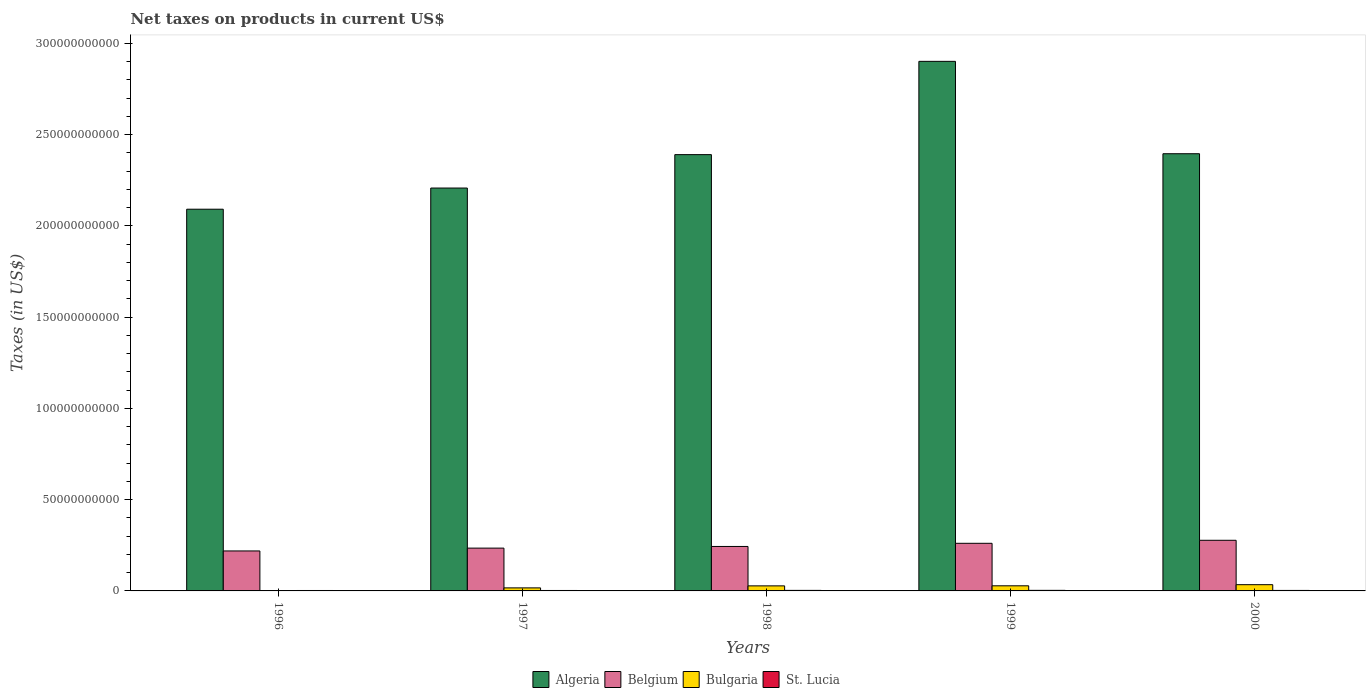How many groups of bars are there?
Your response must be concise. 5. Are the number of bars per tick equal to the number of legend labels?
Offer a terse response. Yes. In how many cases, is the number of bars for a given year not equal to the number of legend labels?
Your response must be concise. 0. What is the net taxes on products in Belgium in 1996?
Provide a short and direct response. 2.19e+1. Across all years, what is the maximum net taxes on products in Belgium?
Provide a short and direct response. 2.77e+1. Across all years, what is the minimum net taxes on products in Belgium?
Your answer should be compact. 2.19e+1. What is the total net taxes on products in St. Lucia in the graph?
Provide a succinct answer. 1.35e+09. What is the difference between the net taxes on products in Belgium in 1997 and that in 2000?
Provide a succinct answer. -4.29e+09. What is the difference between the net taxes on products in Belgium in 1998 and the net taxes on products in Algeria in 1999?
Offer a very short reply. -2.66e+11. What is the average net taxes on products in Belgium per year?
Your answer should be compact. 2.47e+1. In the year 1996, what is the difference between the net taxes on products in Bulgaria and net taxes on products in Algeria?
Offer a terse response. -2.09e+11. What is the ratio of the net taxes on products in Belgium in 1996 to that in 1999?
Provide a short and direct response. 0.84. What is the difference between the highest and the second highest net taxes on products in St. Lucia?
Provide a succinct answer. 1.72e+07. What is the difference between the highest and the lowest net taxes on products in Bulgaria?
Offer a very short reply. 3.23e+09. Is it the case that in every year, the sum of the net taxes on products in St. Lucia and net taxes on products in Algeria is greater than the sum of net taxes on products in Belgium and net taxes on products in Bulgaria?
Offer a terse response. No. What does the 3rd bar from the left in 1998 represents?
Keep it short and to the point. Bulgaria. What does the 1st bar from the right in 1996 represents?
Your response must be concise. St. Lucia. Is it the case that in every year, the sum of the net taxes on products in Bulgaria and net taxes on products in St. Lucia is greater than the net taxes on products in Belgium?
Offer a very short reply. No. How many bars are there?
Make the answer very short. 20. How many years are there in the graph?
Give a very brief answer. 5. What is the difference between two consecutive major ticks on the Y-axis?
Provide a short and direct response. 5.00e+1. How many legend labels are there?
Offer a terse response. 4. What is the title of the graph?
Keep it short and to the point. Net taxes on products in current US$. What is the label or title of the Y-axis?
Keep it short and to the point. Taxes (in US$). What is the Taxes (in US$) of Algeria in 1996?
Offer a terse response. 2.09e+11. What is the Taxes (in US$) of Belgium in 1996?
Offer a very short reply. 2.19e+1. What is the Taxes (in US$) in Bulgaria in 1996?
Your answer should be compact. 1.82e+08. What is the Taxes (in US$) in St. Lucia in 1996?
Your response must be concise. 2.35e+08. What is the Taxes (in US$) in Algeria in 1997?
Your answer should be compact. 2.21e+11. What is the Taxes (in US$) in Belgium in 1997?
Offer a terse response. 2.34e+1. What is the Taxes (in US$) of Bulgaria in 1997?
Offer a very short reply. 1.66e+09. What is the Taxes (in US$) in St. Lucia in 1997?
Provide a succinct answer. 2.40e+08. What is the Taxes (in US$) in Algeria in 1998?
Provide a succinct answer. 2.39e+11. What is the Taxes (in US$) in Belgium in 1998?
Your answer should be very brief. 2.44e+1. What is the Taxes (in US$) of Bulgaria in 1998?
Offer a very short reply. 2.77e+09. What is the Taxes (in US$) in St. Lucia in 1998?
Offer a very short reply. 2.94e+08. What is the Taxes (in US$) in Algeria in 1999?
Your answer should be very brief. 2.90e+11. What is the Taxes (in US$) in Belgium in 1999?
Provide a short and direct response. 2.61e+1. What is the Taxes (in US$) in Bulgaria in 1999?
Ensure brevity in your answer.  2.80e+09. What is the Taxes (in US$) in St. Lucia in 1999?
Give a very brief answer. 3.11e+08. What is the Taxes (in US$) in Algeria in 2000?
Provide a short and direct response. 2.40e+11. What is the Taxes (in US$) in Belgium in 2000?
Ensure brevity in your answer.  2.77e+1. What is the Taxes (in US$) in Bulgaria in 2000?
Your response must be concise. 3.42e+09. What is the Taxes (in US$) of St. Lucia in 2000?
Make the answer very short. 2.73e+08. Across all years, what is the maximum Taxes (in US$) of Algeria?
Give a very brief answer. 2.90e+11. Across all years, what is the maximum Taxes (in US$) of Belgium?
Your answer should be very brief. 2.77e+1. Across all years, what is the maximum Taxes (in US$) of Bulgaria?
Your response must be concise. 3.42e+09. Across all years, what is the maximum Taxes (in US$) in St. Lucia?
Provide a succinct answer. 3.11e+08. Across all years, what is the minimum Taxes (in US$) of Algeria?
Offer a very short reply. 2.09e+11. Across all years, what is the minimum Taxes (in US$) in Belgium?
Your answer should be very brief. 2.19e+1. Across all years, what is the minimum Taxes (in US$) of Bulgaria?
Offer a terse response. 1.82e+08. Across all years, what is the minimum Taxes (in US$) in St. Lucia?
Keep it short and to the point. 2.35e+08. What is the total Taxes (in US$) in Algeria in the graph?
Provide a short and direct response. 1.20e+12. What is the total Taxes (in US$) in Belgium in the graph?
Provide a short and direct response. 1.24e+11. What is the total Taxes (in US$) of Bulgaria in the graph?
Offer a terse response. 1.08e+1. What is the total Taxes (in US$) in St. Lucia in the graph?
Give a very brief answer. 1.35e+09. What is the difference between the Taxes (in US$) in Algeria in 1996 and that in 1997?
Provide a succinct answer. -1.16e+1. What is the difference between the Taxes (in US$) in Belgium in 1996 and that in 1997?
Ensure brevity in your answer.  -1.55e+09. What is the difference between the Taxes (in US$) of Bulgaria in 1996 and that in 1997?
Your answer should be very brief. -1.48e+09. What is the difference between the Taxes (in US$) in St. Lucia in 1996 and that in 1997?
Offer a very short reply. -5.30e+06. What is the difference between the Taxes (in US$) in Algeria in 1996 and that in 1998?
Ensure brevity in your answer.  -2.99e+1. What is the difference between the Taxes (in US$) in Belgium in 1996 and that in 1998?
Keep it short and to the point. -2.46e+09. What is the difference between the Taxes (in US$) of Bulgaria in 1996 and that in 1998?
Your answer should be very brief. -2.58e+09. What is the difference between the Taxes (in US$) of St. Lucia in 1996 and that in 1998?
Ensure brevity in your answer.  -5.86e+07. What is the difference between the Taxes (in US$) of Algeria in 1996 and that in 1999?
Your answer should be compact. -8.10e+1. What is the difference between the Taxes (in US$) of Belgium in 1996 and that in 1999?
Your answer should be compact. -4.19e+09. What is the difference between the Taxes (in US$) of Bulgaria in 1996 and that in 1999?
Provide a short and direct response. -2.62e+09. What is the difference between the Taxes (in US$) in St. Lucia in 1996 and that in 1999?
Give a very brief answer. -7.59e+07. What is the difference between the Taxes (in US$) in Algeria in 1996 and that in 2000?
Ensure brevity in your answer.  -3.04e+1. What is the difference between the Taxes (in US$) in Belgium in 1996 and that in 2000?
Ensure brevity in your answer.  -5.84e+09. What is the difference between the Taxes (in US$) in Bulgaria in 1996 and that in 2000?
Provide a short and direct response. -3.23e+09. What is the difference between the Taxes (in US$) in St. Lucia in 1996 and that in 2000?
Your answer should be compact. -3.77e+07. What is the difference between the Taxes (in US$) of Algeria in 1997 and that in 1998?
Offer a terse response. -1.83e+1. What is the difference between the Taxes (in US$) in Belgium in 1997 and that in 1998?
Offer a very short reply. -9.08e+08. What is the difference between the Taxes (in US$) in Bulgaria in 1997 and that in 1998?
Provide a short and direct response. -1.11e+09. What is the difference between the Taxes (in US$) of St. Lucia in 1997 and that in 1998?
Keep it short and to the point. -5.33e+07. What is the difference between the Taxes (in US$) in Algeria in 1997 and that in 1999?
Give a very brief answer. -6.94e+1. What is the difference between the Taxes (in US$) of Belgium in 1997 and that in 1999?
Your answer should be compact. -2.64e+09. What is the difference between the Taxes (in US$) in Bulgaria in 1997 and that in 1999?
Your answer should be compact. -1.14e+09. What is the difference between the Taxes (in US$) of St. Lucia in 1997 and that in 1999?
Your answer should be very brief. -7.06e+07. What is the difference between the Taxes (in US$) of Algeria in 1997 and that in 2000?
Provide a succinct answer. -1.88e+1. What is the difference between the Taxes (in US$) of Belgium in 1997 and that in 2000?
Provide a short and direct response. -4.29e+09. What is the difference between the Taxes (in US$) of Bulgaria in 1997 and that in 2000?
Your answer should be compact. -1.76e+09. What is the difference between the Taxes (in US$) of St. Lucia in 1997 and that in 2000?
Your answer should be very brief. -3.24e+07. What is the difference between the Taxes (in US$) of Algeria in 1998 and that in 1999?
Ensure brevity in your answer.  -5.11e+1. What is the difference between the Taxes (in US$) of Belgium in 1998 and that in 1999?
Provide a short and direct response. -1.73e+09. What is the difference between the Taxes (in US$) of Bulgaria in 1998 and that in 1999?
Offer a very short reply. -3.45e+07. What is the difference between the Taxes (in US$) of St. Lucia in 1998 and that in 1999?
Make the answer very short. -1.72e+07. What is the difference between the Taxes (in US$) of Algeria in 1998 and that in 2000?
Your response must be concise. -5.00e+08. What is the difference between the Taxes (in US$) in Belgium in 1998 and that in 2000?
Ensure brevity in your answer.  -3.38e+09. What is the difference between the Taxes (in US$) of Bulgaria in 1998 and that in 2000?
Your answer should be compact. -6.50e+08. What is the difference between the Taxes (in US$) in St. Lucia in 1998 and that in 2000?
Provide a succinct answer. 2.09e+07. What is the difference between the Taxes (in US$) of Algeria in 1999 and that in 2000?
Give a very brief answer. 5.06e+1. What is the difference between the Taxes (in US$) of Belgium in 1999 and that in 2000?
Provide a succinct answer. -1.65e+09. What is the difference between the Taxes (in US$) of Bulgaria in 1999 and that in 2000?
Make the answer very short. -6.16e+08. What is the difference between the Taxes (in US$) in St. Lucia in 1999 and that in 2000?
Ensure brevity in your answer.  3.81e+07. What is the difference between the Taxes (in US$) in Algeria in 1996 and the Taxes (in US$) in Belgium in 1997?
Give a very brief answer. 1.86e+11. What is the difference between the Taxes (in US$) in Algeria in 1996 and the Taxes (in US$) in Bulgaria in 1997?
Offer a very short reply. 2.07e+11. What is the difference between the Taxes (in US$) of Algeria in 1996 and the Taxes (in US$) of St. Lucia in 1997?
Your response must be concise. 2.09e+11. What is the difference between the Taxes (in US$) in Belgium in 1996 and the Taxes (in US$) in Bulgaria in 1997?
Offer a very short reply. 2.02e+1. What is the difference between the Taxes (in US$) of Belgium in 1996 and the Taxes (in US$) of St. Lucia in 1997?
Give a very brief answer. 2.17e+1. What is the difference between the Taxes (in US$) in Bulgaria in 1996 and the Taxes (in US$) in St. Lucia in 1997?
Your answer should be very brief. -5.87e+07. What is the difference between the Taxes (in US$) in Algeria in 1996 and the Taxes (in US$) in Belgium in 1998?
Give a very brief answer. 1.85e+11. What is the difference between the Taxes (in US$) in Algeria in 1996 and the Taxes (in US$) in Bulgaria in 1998?
Give a very brief answer. 2.06e+11. What is the difference between the Taxes (in US$) of Algeria in 1996 and the Taxes (in US$) of St. Lucia in 1998?
Make the answer very short. 2.09e+11. What is the difference between the Taxes (in US$) in Belgium in 1996 and the Taxes (in US$) in Bulgaria in 1998?
Offer a terse response. 1.91e+1. What is the difference between the Taxes (in US$) in Belgium in 1996 and the Taxes (in US$) in St. Lucia in 1998?
Your response must be concise. 2.16e+1. What is the difference between the Taxes (in US$) of Bulgaria in 1996 and the Taxes (in US$) of St. Lucia in 1998?
Provide a succinct answer. -1.12e+08. What is the difference between the Taxes (in US$) of Algeria in 1996 and the Taxes (in US$) of Belgium in 1999?
Make the answer very short. 1.83e+11. What is the difference between the Taxes (in US$) in Algeria in 1996 and the Taxes (in US$) in Bulgaria in 1999?
Your answer should be very brief. 2.06e+11. What is the difference between the Taxes (in US$) of Algeria in 1996 and the Taxes (in US$) of St. Lucia in 1999?
Offer a very short reply. 2.09e+11. What is the difference between the Taxes (in US$) in Belgium in 1996 and the Taxes (in US$) in Bulgaria in 1999?
Your answer should be very brief. 1.91e+1. What is the difference between the Taxes (in US$) in Belgium in 1996 and the Taxes (in US$) in St. Lucia in 1999?
Your answer should be very brief. 2.16e+1. What is the difference between the Taxes (in US$) of Bulgaria in 1996 and the Taxes (in US$) of St. Lucia in 1999?
Offer a very short reply. -1.29e+08. What is the difference between the Taxes (in US$) in Algeria in 1996 and the Taxes (in US$) in Belgium in 2000?
Keep it short and to the point. 1.81e+11. What is the difference between the Taxes (in US$) in Algeria in 1996 and the Taxes (in US$) in Bulgaria in 2000?
Keep it short and to the point. 2.06e+11. What is the difference between the Taxes (in US$) of Algeria in 1996 and the Taxes (in US$) of St. Lucia in 2000?
Your answer should be compact. 2.09e+11. What is the difference between the Taxes (in US$) in Belgium in 1996 and the Taxes (in US$) in Bulgaria in 2000?
Your answer should be very brief. 1.85e+1. What is the difference between the Taxes (in US$) in Belgium in 1996 and the Taxes (in US$) in St. Lucia in 2000?
Give a very brief answer. 2.16e+1. What is the difference between the Taxes (in US$) of Bulgaria in 1996 and the Taxes (in US$) of St. Lucia in 2000?
Your answer should be compact. -9.11e+07. What is the difference between the Taxes (in US$) in Algeria in 1997 and the Taxes (in US$) in Belgium in 1998?
Provide a succinct answer. 1.96e+11. What is the difference between the Taxes (in US$) in Algeria in 1997 and the Taxes (in US$) in Bulgaria in 1998?
Make the answer very short. 2.18e+11. What is the difference between the Taxes (in US$) in Algeria in 1997 and the Taxes (in US$) in St. Lucia in 1998?
Ensure brevity in your answer.  2.20e+11. What is the difference between the Taxes (in US$) of Belgium in 1997 and the Taxes (in US$) of Bulgaria in 1998?
Provide a succinct answer. 2.07e+1. What is the difference between the Taxes (in US$) in Belgium in 1997 and the Taxes (in US$) in St. Lucia in 1998?
Offer a terse response. 2.32e+1. What is the difference between the Taxes (in US$) in Bulgaria in 1997 and the Taxes (in US$) in St. Lucia in 1998?
Make the answer very short. 1.37e+09. What is the difference between the Taxes (in US$) of Algeria in 1997 and the Taxes (in US$) of Belgium in 1999?
Your answer should be compact. 1.95e+11. What is the difference between the Taxes (in US$) of Algeria in 1997 and the Taxes (in US$) of Bulgaria in 1999?
Offer a very short reply. 2.18e+11. What is the difference between the Taxes (in US$) of Algeria in 1997 and the Taxes (in US$) of St. Lucia in 1999?
Give a very brief answer. 2.20e+11. What is the difference between the Taxes (in US$) in Belgium in 1997 and the Taxes (in US$) in Bulgaria in 1999?
Your answer should be compact. 2.06e+1. What is the difference between the Taxes (in US$) of Belgium in 1997 and the Taxes (in US$) of St. Lucia in 1999?
Your response must be concise. 2.31e+1. What is the difference between the Taxes (in US$) in Bulgaria in 1997 and the Taxes (in US$) in St. Lucia in 1999?
Your response must be concise. 1.35e+09. What is the difference between the Taxes (in US$) in Algeria in 1997 and the Taxes (in US$) in Belgium in 2000?
Provide a succinct answer. 1.93e+11. What is the difference between the Taxes (in US$) in Algeria in 1997 and the Taxes (in US$) in Bulgaria in 2000?
Provide a succinct answer. 2.17e+11. What is the difference between the Taxes (in US$) of Algeria in 1997 and the Taxes (in US$) of St. Lucia in 2000?
Your response must be concise. 2.20e+11. What is the difference between the Taxes (in US$) in Belgium in 1997 and the Taxes (in US$) in Bulgaria in 2000?
Make the answer very short. 2.00e+1. What is the difference between the Taxes (in US$) of Belgium in 1997 and the Taxes (in US$) of St. Lucia in 2000?
Provide a short and direct response. 2.32e+1. What is the difference between the Taxes (in US$) in Bulgaria in 1997 and the Taxes (in US$) in St. Lucia in 2000?
Provide a succinct answer. 1.39e+09. What is the difference between the Taxes (in US$) of Algeria in 1998 and the Taxes (in US$) of Belgium in 1999?
Offer a terse response. 2.13e+11. What is the difference between the Taxes (in US$) of Algeria in 1998 and the Taxes (in US$) of Bulgaria in 1999?
Provide a short and direct response. 2.36e+11. What is the difference between the Taxes (in US$) of Algeria in 1998 and the Taxes (in US$) of St. Lucia in 1999?
Provide a short and direct response. 2.39e+11. What is the difference between the Taxes (in US$) in Belgium in 1998 and the Taxes (in US$) in Bulgaria in 1999?
Provide a short and direct response. 2.16e+1. What is the difference between the Taxes (in US$) in Belgium in 1998 and the Taxes (in US$) in St. Lucia in 1999?
Provide a succinct answer. 2.40e+1. What is the difference between the Taxes (in US$) of Bulgaria in 1998 and the Taxes (in US$) of St. Lucia in 1999?
Your answer should be very brief. 2.46e+09. What is the difference between the Taxes (in US$) of Algeria in 1998 and the Taxes (in US$) of Belgium in 2000?
Keep it short and to the point. 2.11e+11. What is the difference between the Taxes (in US$) of Algeria in 1998 and the Taxes (in US$) of Bulgaria in 2000?
Offer a very short reply. 2.36e+11. What is the difference between the Taxes (in US$) of Algeria in 1998 and the Taxes (in US$) of St. Lucia in 2000?
Provide a short and direct response. 2.39e+11. What is the difference between the Taxes (in US$) of Belgium in 1998 and the Taxes (in US$) of Bulgaria in 2000?
Keep it short and to the point. 2.09e+1. What is the difference between the Taxes (in US$) in Belgium in 1998 and the Taxes (in US$) in St. Lucia in 2000?
Your answer should be compact. 2.41e+1. What is the difference between the Taxes (in US$) of Bulgaria in 1998 and the Taxes (in US$) of St. Lucia in 2000?
Your response must be concise. 2.49e+09. What is the difference between the Taxes (in US$) of Algeria in 1999 and the Taxes (in US$) of Belgium in 2000?
Provide a succinct answer. 2.62e+11. What is the difference between the Taxes (in US$) in Algeria in 1999 and the Taxes (in US$) in Bulgaria in 2000?
Make the answer very short. 2.87e+11. What is the difference between the Taxes (in US$) of Algeria in 1999 and the Taxes (in US$) of St. Lucia in 2000?
Make the answer very short. 2.90e+11. What is the difference between the Taxes (in US$) in Belgium in 1999 and the Taxes (in US$) in Bulgaria in 2000?
Ensure brevity in your answer.  2.27e+1. What is the difference between the Taxes (in US$) of Belgium in 1999 and the Taxes (in US$) of St. Lucia in 2000?
Provide a short and direct response. 2.58e+1. What is the difference between the Taxes (in US$) of Bulgaria in 1999 and the Taxes (in US$) of St. Lucia in 2000?
Your answer should be compact. 2.53e+09. What is the average Taxes (in US$) in Algeria per year?
Offer a very short reply. 2.40e+11. What is the average Taxes (in US$) in Belgium per year?
Your answer should be compact. 2.47e+1. What is the average Taxes (in US$) in Bulgaria per year?
Make the answer very short. 2.16e+09. What is the average Taxes (in US$) in St. Lucia per year?
Provide a short and direct response. 2.71e+08. In the year 1996, what is the difference between the Taxes (in US$) in Algeria and Taxes (in US$) in Belgium?
Provide a short and direct response. 1.87e+11. In the year 1996, what is the difference between the Taxes (in US$) of Algeria and Taxes (in US$) of Bulgaria?
Give a very brief answer. 2.09e+11. In the year 1996, what is the difference between the Taxes (in US$) of Algeria and Taxes (in US$) of St. Lucia?
Provide a short and direct response. 2.09e+11. In the year 1996, what is the difference between the Taxes (in US$) in Belgium and Taxes (in US$) in Bulgaria?
Keep it short and to the point. 2.17e+1. In the year 1996, what is the difference between the Taxes (in US$) in Belgium and Taxes (in US$) in St. Lucia?
Offer a terse response. 2.17e+1. In the year 1996, what is the difference between the Taxes (in US$) in Bulgaria and Taxes (in US$) in St. Lucia?
Your answer should be compact. -5.34e+07. In the year 1997, what is the difference between the Taxes (in US$) of Algeria and Taxes (in US$) of Belgium?
Give a very brief answer. 1.97e+11. In the year 1997, what is the difference between the Taxes (in US$) in Algeria and Taxes (in US$) in Bulgaria?
Ensure brevity in your answer.  2.19e+11. In the year 1997, what is the difference between the Taxes (in US$) of Algeria and Taxes (in US$) of St. Lucia?
Make the answer very short. 2.20e+11. In the year 1997, what is the difference between the Taxes (in US$) in Belgium and Taxes (in US$) in Bulgaria?
Your answer should be very brief. 2.18e+1. In the year 1997, what is the difference between the Taxes (in US$) in Belgium and Taxes (in US$) in St. Lucia?
Offer a very short reply. 2.32e+1. In the year 1997, what is the difference between the Taxes (in US$) in Bulgaria and Taxes (in US$) in St. Lucia?
Provide a short and direct response. 1.42e+09. In the year 1998, what is the difference between the Taxes (in US$) of Algeria and Taxes (in US$) of Belgium?
Offer a very short reply. 2.15e+11. In the year 1998, what is the difference between the Taxes (in US$) in Algeria and Taxes (in US$) in Bulgaria?
Your answer should be very brief. 2.36e+11. In the year 1998, what is the difference between the Taxes (in US$) in Algeria and Taxes (in US$) in St. Lucia?
Give a very brief answer. 2.39e+11. In the year 1998, what is the difference between the Taxes (in US$) of Belgium and Taxes (in US$) of Bulgaria?
Your response must be concise. 2.16e+1. In the year 1998, what is the difference between the Taxes (in US$) in Belgium and Taxes (in US$) in St. Lucia?
Your answer should be compact. 2.41e+1. In the year 1998, what is the difference between the Taxes (in US$) in Bulgaria and Taxes (in US$) in St. Lucia?
Ensure brevity in your answer.  2.47e+09. In the year 1999, what is the difference between the Taxes (in US$) of Algeria and Taxes (in US$) of Belgium?
Your response must be concise. 2.64e+11. In the year 1999, what is the difference between the Taxes (in US$) of Algeria and Taxes (in US$) of Bulgaria?
Ensure brevity in your answer.  2.87e+11. In the year 1999, what is the difference between the Taxes (in US$) of Algeria and Taxes (in US$) of St. Lucia?
Provide a short and direct response. 2.90e+11. In the year 1999, what is the difference between the Taxes (in US$) of Belgium and Taxes (in US$) of Bulgaria?
Provide a succinct answer. 2.33e+1. In the year 1999, what is the difference between the Taxes (in US$) in Belgium and Taxes (in US$) in St. Lucia?
Make the answer very short. 2.58e+1. In the year 1999, what is the difference between the Taxes (in US$) in Bulgaria and Taxes (in US$) in St. Lucia?
Your response must be concise. 2.49e+09. In the year 2000, what is the difference between the Taxes (in US$) in Algeria and Taxes (in US$) in Belgium?
Give a very brief answer. 2.12e+11. In the year 2000, what is the difference between the Taxes (in US$) of Algeria and Taxes (in US$) of Bulgaria?
Ensure brevity in your answer.  2.36e+11. In the year 2000, what is the difference between the Taxes (in US$) of Algeria and Taxes (in US$) of St. Lucia?
Your response must be concise. 2.39e+11. In the year 2000, what is the difference between the Taxes (in US$) in Belgium and Taxes (in US$) in Bulgaria?
Offer a terse response. 2.43e+1. In the year 2000, what is the difference between the Taxes (in US$) of Belgium and Taxes (in US$) of St. Lucia?
Offer a terse response. 2.75e+1. In the year 2000, what is the difference between the Taxes (in US$) of Bulgaria and Taxes (in US$) of St. Lucia?
Ensure brevity in your answer.  3.14e+09. What is the ratio of the Taxes (in US$) in Algeria in 1996 to that in 1997?
Your response must be concise. 0.95. What is the ratio of the Taxes (in US$) in Belgium in 1996 to that in 1997?
Keep it short and to the point. 0.93. What is the ratio of the Taxes (in US$) of Bulgaria in 1996 to that in 1997?
Ensure brevity in your answer.  0.11. What is the ratio of the Taxes (in US$) in St. Lucia in 1996 to that in 1997?
Your answer should be compact. 0.98. What is the ratio of the Taxes (in US$) in Algeria in 1996 to that in 1998?
Offer a very short reply. 0.87. What is the ratio of the Taxes (in US$) of Belgium in 1996 to that in 1998?
Ensure brevity in your answer.  0.9. What is the ratio of the Taxes (in US$) in Bulgaria in 1996 to that in 1998?
Your answer should be compact. 0.07. What is the ratio of the Taxes (in US$) of St. Lucia in 1996 to that in 1998?
Provide a succinct answer. 0.8. What is the ratio of the Taxes (in US$) of Algeria in 1996 to that in 1999?
Keep it short and to the point. 0.72. What is the ratio of the Taxes (in US$) of Belgium in 1996 to that in 1999?
Ensure brevity in your answer.  0.84. What is the ratio of the Taxes (in US$) in Bulgaria in 1996 to that in 1999?
Your response must be concise. 0.06. What is the ratio of the Taxes (in US$) in St. Lucia in 1996 to that in 1999?
Offer a very short reply. 0.76. What is the ratio of the Taxes (in US$) of Algeria in 1996 to that in 2000?
Make the answer very short. 0.87. What is the ratio of the Taxes (in US$) in Belgium in 1996 to that in 2000?
Ensure brevity in your answer.  0.79. What is the ratio of the Taxes (in US$) of Bulgaria in 1996 to that in 2000?
Keep it short and to the point. 0.05. What is the ratio of the Taxes (in US$) of St. Lucia in 1996 to that in 2000?
Provide a succinct answer. 0.86. What is the ratio of the Taxes (in US$) of Algeria in 1997 to that in 1998?
Your response must be concise. 0.92. What is the ratio of the Taxes (in US$) of Belgium in 1997 to that in 1998?
Give a very brief answer. 0.96. What is the ratio of the Taxes (in US$) in Bulgaria in 1997 to that in 1998?
Make the answer very short. 0.6. What is the ratio of the Taxes (in US$) of St. Lucia in 1997 to that in 1998?
Keep it short and to the point. 0.82. What is the ratio of the Taxes (in US$) in Algeria in 1997 to that in 1999?
Keep it short and to the point. 0.76. What is the ratio of the Taxes (in US$) of Belgium in 1997 to that in 1999?
Provide a short and direct response. 0.9. What is the ratio of the Taxes (in US$) of Bulgaria in 1997 to that in 1999?
Give a very brief answer. 0.59. What is the ratio of the Taxes (in US$) in St. Lucia in 1997 to that in 1999?
Your response must be concise. 0.77. What is the ratio of the Taxes (in US$) of Algeria in 1997 to that in 2000?
Your response must be concise. 0.92. What is the ratio of the Taxes (in US$) in Belgium in 1997 to that in 2000?
Your response must be concise. 0.85. What is the ratio of the Taxes (in US$) of Bulgaria in 1997 to that in 2000?
Offer a terse response. 0.49. What is the ratio of the Taxes (in US$) of St. Lucia in 1997 to that in 2000?
Offer a terse response. 0.88. What is the ratio of the Taxes (in US$) of Algeria in 1998 to that in 1999?
Your answer should be compact. 0.82. What is the ratio of the Taxes (in US$) of Belgium in 1998 to that in 1999?
Your response must be concise. 0.93. What is the ratio of the Taxes (in US$) in Bulgaria in 1998 to that in 1999?
Keep it short and to the point. 0.99. What is the ratio of the Taxes (in US$) of St. Lucia in 1998 to that in 1999?
Keep it short and to the point. 0.94. What is the ratio of the Taxes (in US$) of Algeria in 1998 to that in 2000?
Your answer should be very brief. 1. What is the ratio of the Taxes (in US$) of Belgium in 1998 to that in 2000?
Keep it short and to the point. 0.88. What is the ratio of the Taxes (in US$) of Bulgaria in 1998 to that in 2000?
Keep it short and to the point. 0.81. What is the ratio of the Taxes (in US$) in St. Lucia in 1998 to that in 2000?
Keep it short and to the point. 1.08. What is the ratio of the Taxes (in US$) in Algeria in 1999 to that in 2000?
Offer a very short reply. 1.21. What is the ratio of the Taxes (in US$) of Belgium in 1999 to that in 2000?
Offer a very short reply. 0.94. What is the ratio of the Taxes (in US$) in Bulgaria in 1999 to that in 2000?
Offer a very short reply. 0.82. What is the ratio of the Taxes (in US$) in St. Lucia in 1999 to that in 2000?
Your answer should be very brief. 1.14. What is the difference between the highest and the second highest Taxes (in US$) in Algeria?
Provide a short and direct response. 5.06e+1. What is the difference between the highest and the second highest Taxes (in US$) of Belgium?
Your response must be concise. 1.65e+09. What is the difference between the highest and the second highest Taxes (in US$) of Bulgaria?
Provide a short and direct response. 6.16e+08. What is the difference between the highest and the second highest Taxes (in US$) in St. Lucia?
Ensure brevity in your answer.  1.72e+07. What is the difference between the highest and the lowest Taxes (in US$) in Algeria?
Offer a very short reply. 8.10e+1. What is the difference between the highest and the lowest Taxes (in US$) in Belgium?
Make the answer very short. 5.84e+09. What is the difference between the highest and the lowest Taxes (in US$) of Bulgaria?
Your response must be concise. 3.23e+09. What is the difference between the highest and the lowest Taxes (in US$) in St. Lucia?
Your answer should be very brief. 7.59e+07. 